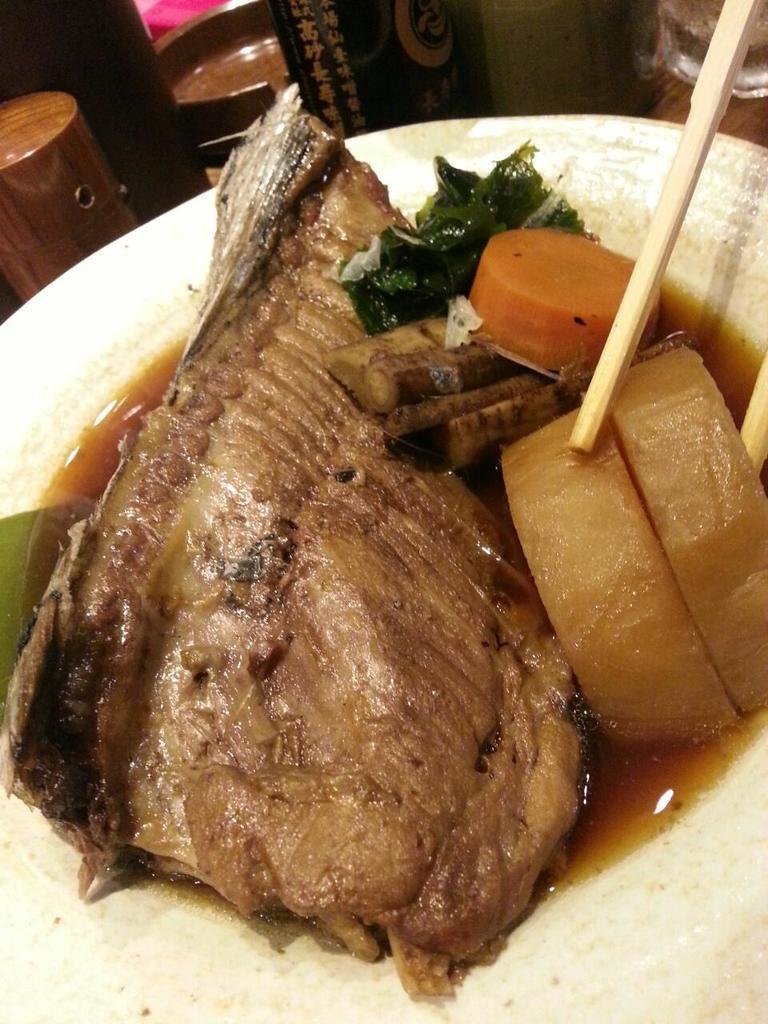How would you summarize this image in a sentence or two? In this image there is a food item kept in a white color plate as we can see in the middle of this image,and there are some objects kept at the top of this image. 